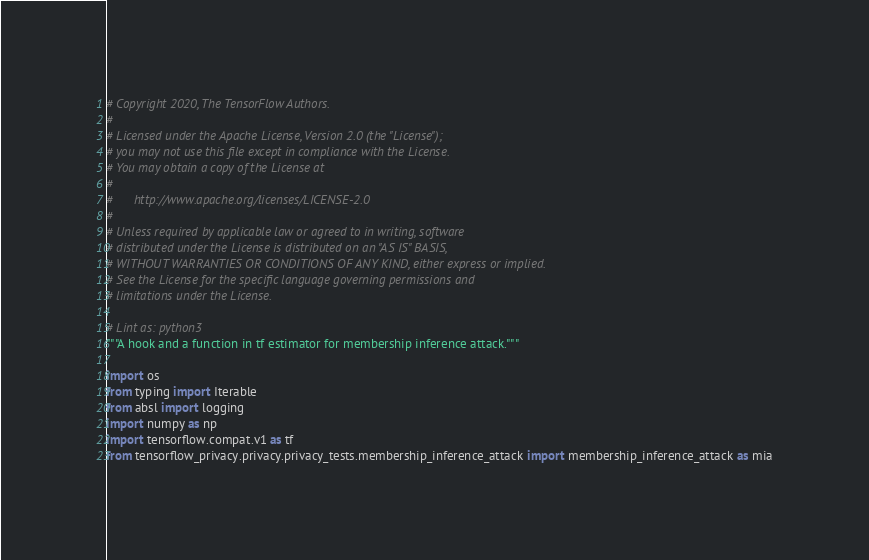<code> <loc_0><loc_0><loc_500><loc_500><_Python_># Copyright 2020, The TensorFlow Authors.
#
# Licensed under the Apache License, Version 2.0 (the "License");
# you may not use this file except in compliance with the License.
# You may obtain a copy of the License at
#
#      http://www.apache.org/licenses/LICENSE-2.0
#
# Unless required by applicable law or agreed to in writing, software
# distributed under the License is distributed on an "AS IS" BASIS,
# WITHOUT WARRANTIES OR CONDITIONS OF ANY KIND, either express or implied.
# See the License for the specific language governing permissions and
# limitations under the License.

# Lint as: python3
"""A hook and a function in tf estimator for membership inference attack."""

import os
from typing import Iterable
from absl import logging
import numpy as np
import tensorflow.compat.v1 as tf
from tensorflow_privacy.privacy.privacy_tests.membership_inference_attack import membership_inference_attack as mia</code> 